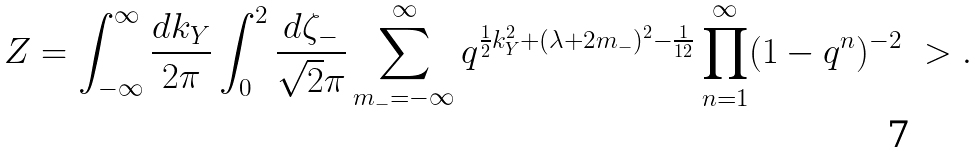<formula> <loc_0><loc_0><loc_500><loc_500>Z = \int _ { - \infty } ^ { \infty } \frac { d k _ { Y } } { 2 \pi } \int _ { 0 } ^ { 2 } \frac { d \zeta _ { - } } { \sqrt { 2 } \pi } \sum _ { m _ { - } = - \infty } ^ { \infty } q ^ { \frac { 1 } { 2 } k _ { Y } ^ { 2 } + ( \lambda + 2 m _ { - } ) ^ { 2 } - \frac { 1 } { 1 2 } } \prod _ { n = 1 } ^ { \infty } ( 1 - q ^ { n } ) ^ { - 2 } \ > .</formula> 